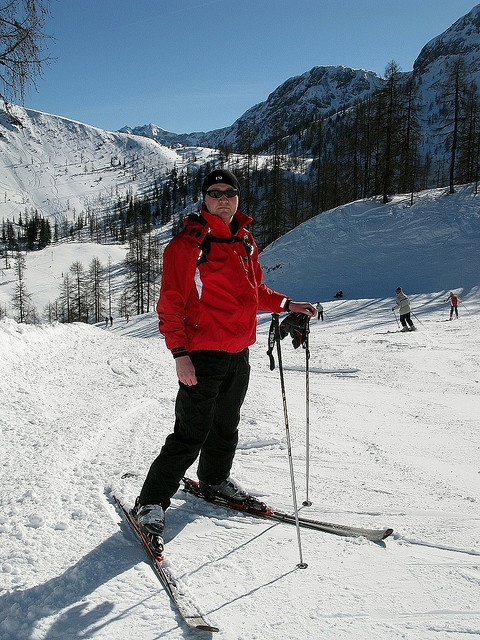Describe the objects in this image and their specific colors. I can see people in gray, black, maroon, and lightgray tones, skis in gray, black, lightgray, and darkgray tones, people in gray, black, darkgray, and lightgray tones, people in gray, black, maroon, and darkgray tones, and people in gray, black, darkgray, and blue tones in this image. 